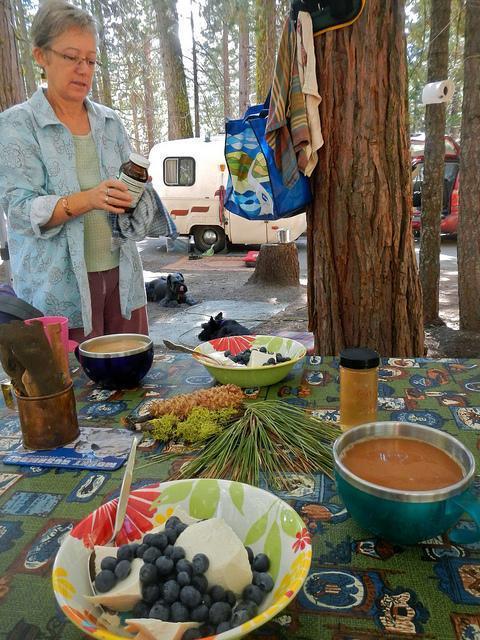How many bowls are there?
Give a very brief answer. 4. 